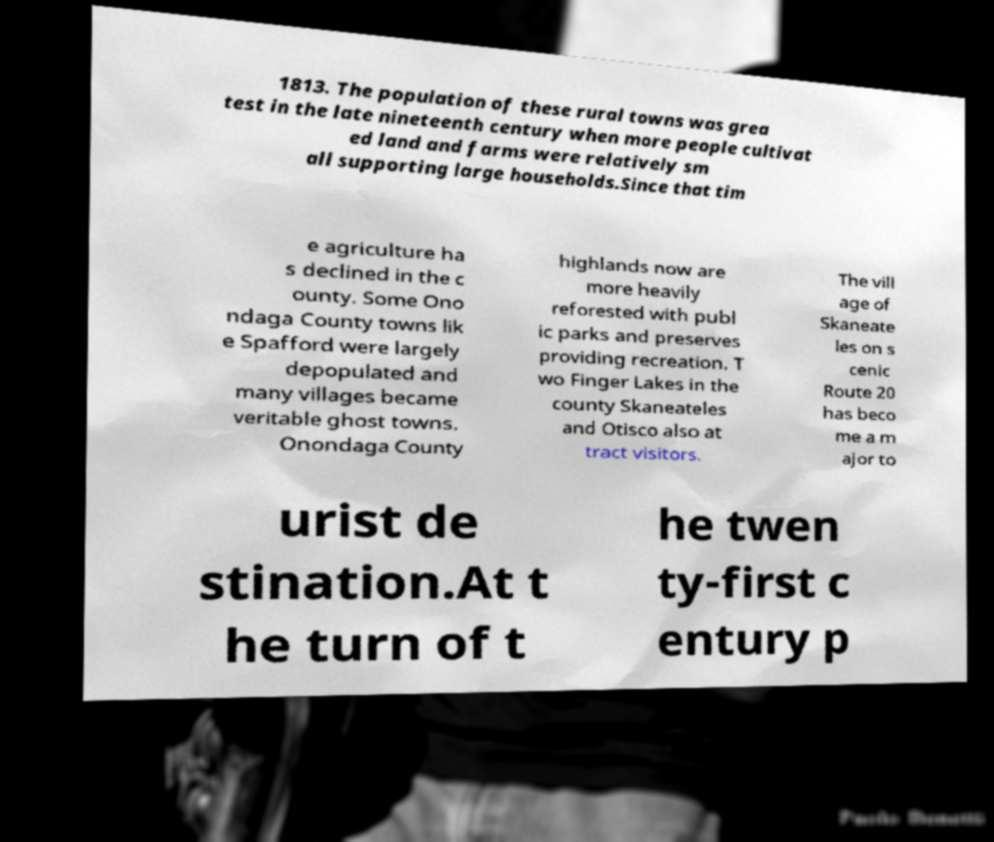Could you assist in decoding the text presented in this image and type it out clearly? 1813. The population of these rural towns was grea test in the late nineteenth century when more people cultivat ed land and farms were relatively sm all supporting large households.Since that tim e agriculture ha s declined in the c ounty. Some Ono ndaga County towns lik e Spafford were largely depopulated and many villages became veritable ghost towns. Onondaga County highlands now are more heavily reforested with publ ic parks and preserves providing recreation. T wo Finger Lakes in the county Skaneateles and Otisco also at tract visitors. The vill age of Skaneate les on s cenic Route 20 has beco me a m ajor to urist de stination.At t he turn of t he twen ty-first c entury p 